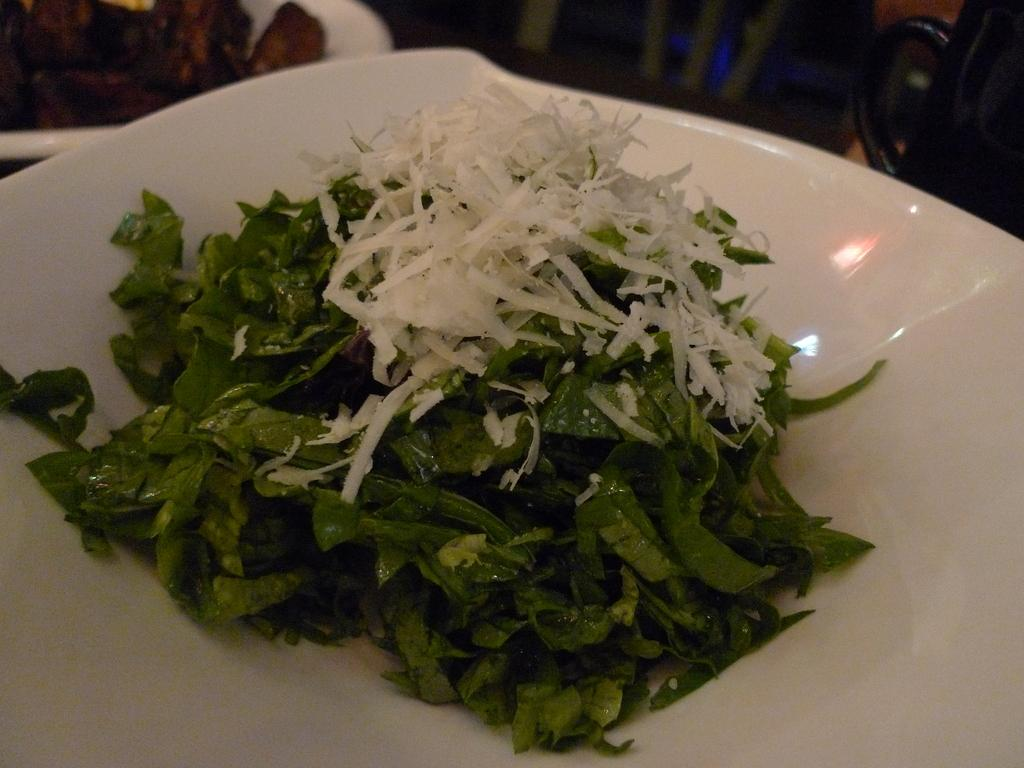What object is in the center of the image? There is a plate in the center of the image. What is on the plate? The plate contains green leafy vegetables. How many connections are visible between the plate and the vegetables in the image? There are no connections visible between the plate and the vegetables in the image; the vegetables are simply on the plate. 